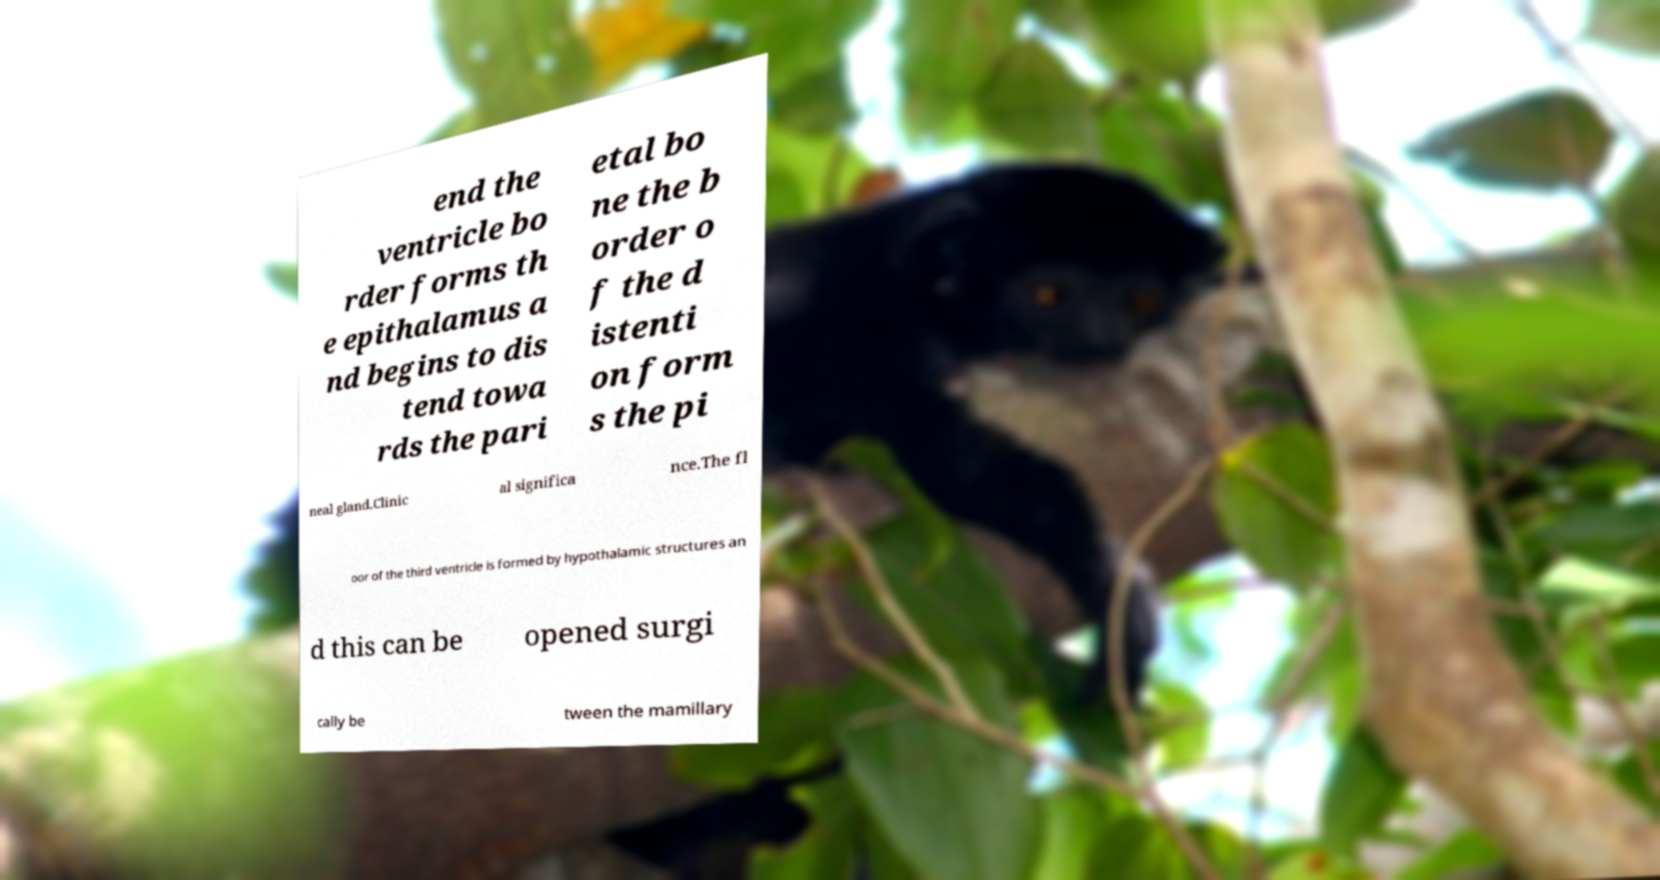Could you extract and type out the text from this image? end the ventricle bo rder forms th e epithalamus a nd begins to dis tend towa rds the pari etal bo ne the b order o f the d istenti on form s the pi neal gland.Clinic al significa nce.The fl oor of the third ventricle is formed by hypothalamic structures an d this can be opened surgi cally be tween the mamillary 